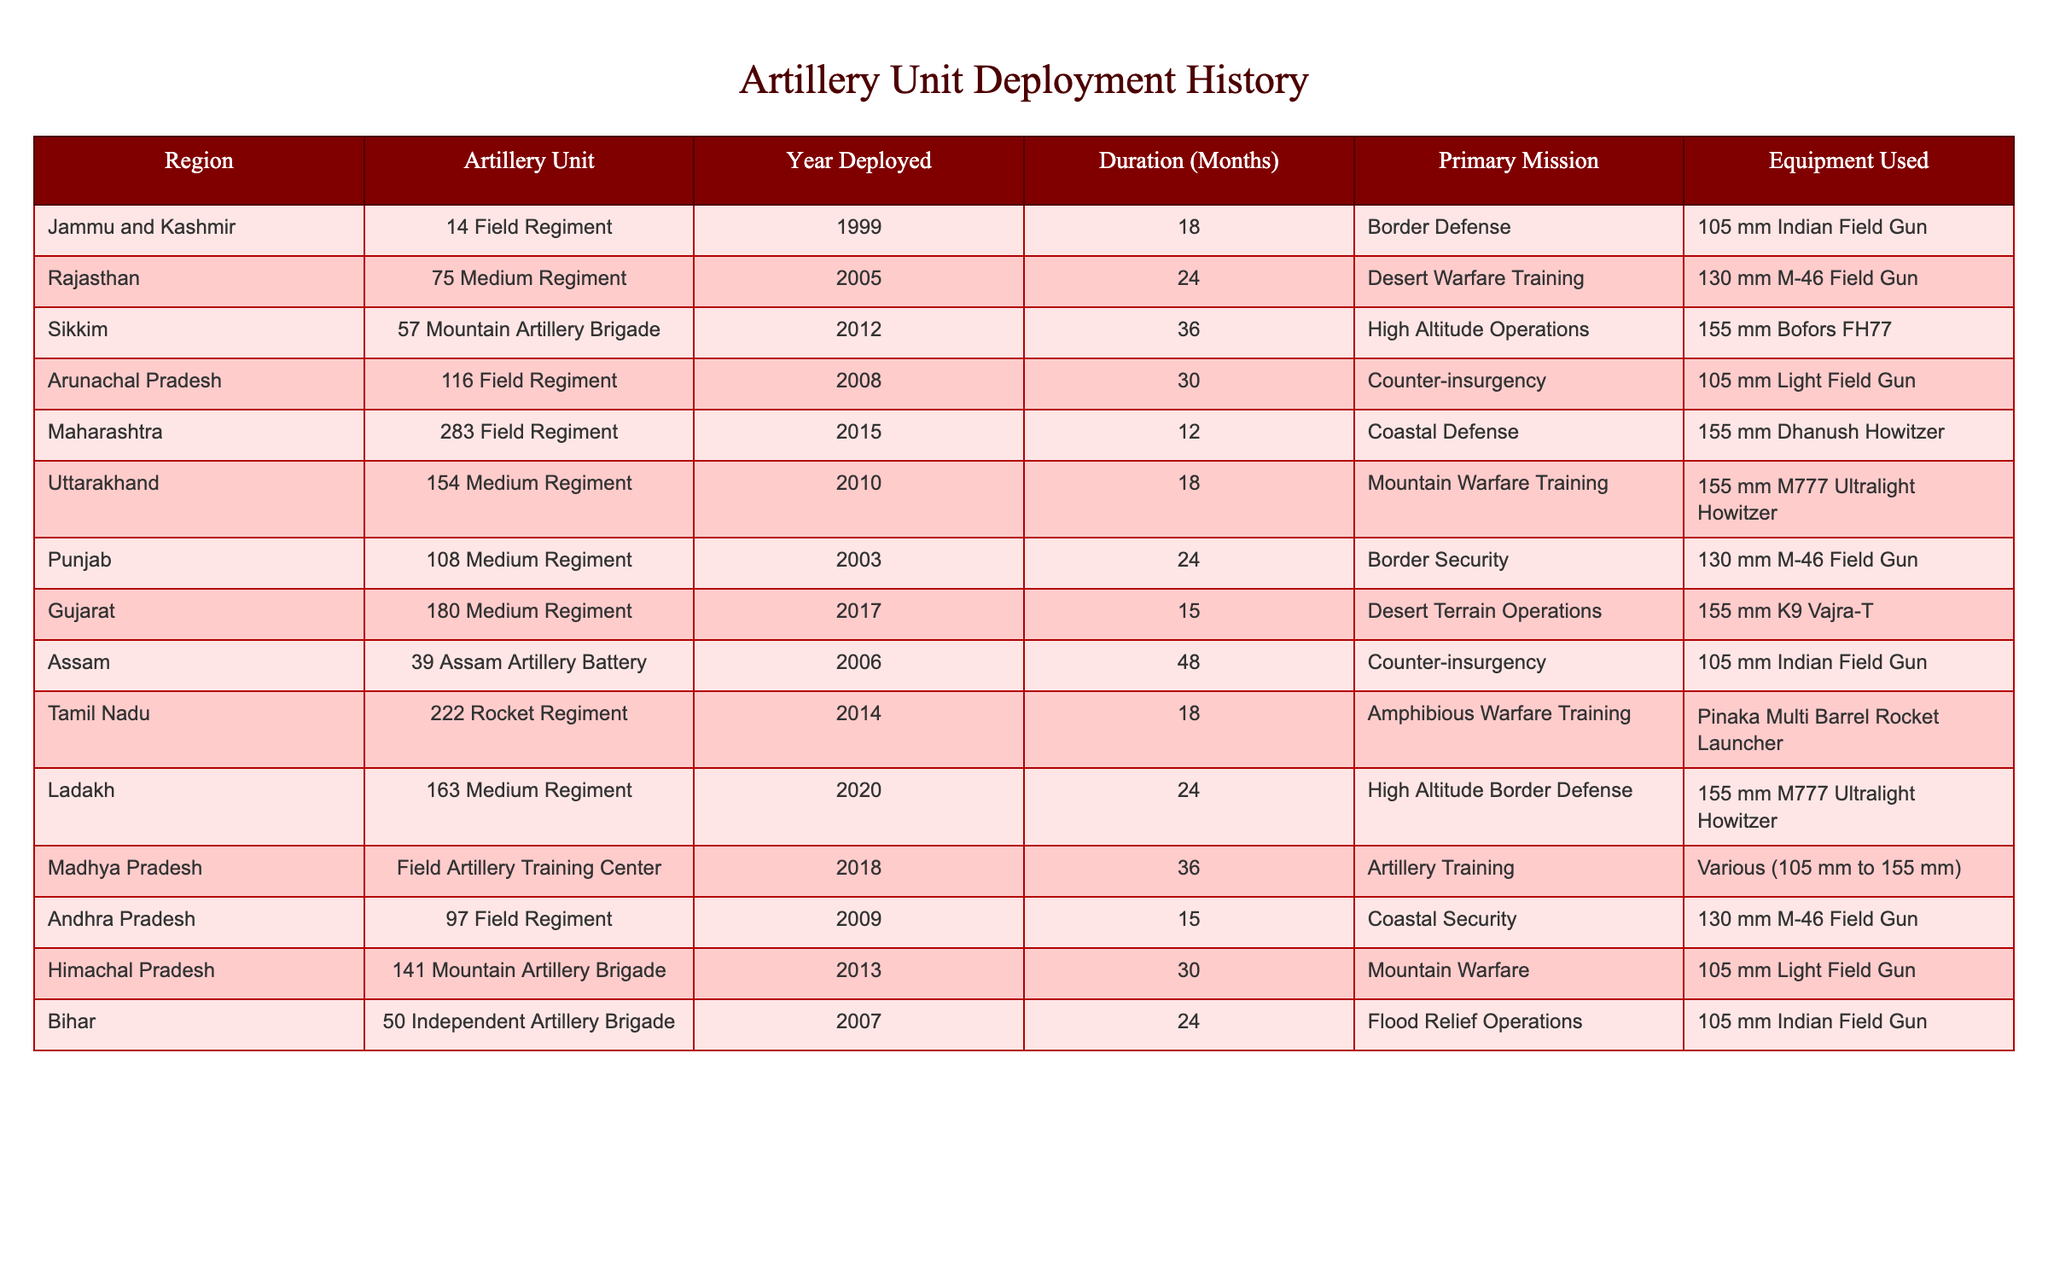What region had the longest deployment duration for artillery units? The longest deployment duration is 48 months, which is for the Assam region. I found this by scanning the "Duration (Months)" column and identifying the maximum value.
Answer: Assam Which artillery unit was deployed in Jammu and Kashmir? The artillery unit deployed in Jammu and Kashmir is the 14 Field Regiment. This is directly stated in the "Artillery Unit" column corresponding to the Jammu and Kashmir row.
Answer: 14 Field Regiment How many months was the 75 Medium Regiment deployed? The 75 Medium Regiment was deployed for 24 months, as noted in the "Duration (Months)" column for that unit.
Answer: 24 months Did any artillery units get deployed for more than 30 months? Yes, the Assam Artillery Battery had a deployment duration of 48 months, which is more than 30 months. To confirm, I checked the "Duration (Months)" column for values greater than 30 and found the relevant entries.
Answer: Yes What is the primary mission of the 222 Rocket Regiment? The primary mission of the 222 Rocket Regiment is Amphibious Warfare Training, as indicated in the "Primary Mission" column for that unit.
Answer: Amphibious Warfare Training How many different types of equipment were used across all the artillery deployments? There are 6 different types of equipment listed in the "Equipment Used" column. I tallied the unique entries from that column: 105 mm Indian Field Gun, 130 mm M-46 Field Gun, 155 mm Bofors FH77, 105 mm Light Field Gun, 155 mm Dhanush Howitzer, 155 mm M777 Ultralight Howitzer, 155 mm K9 Vajra-T, and Pinaka Multi Barrel Rocket Launcher.
Answer: 8 Which region had the second-longest deployment duration? The region with the second-longest deployment duration is Jammu and Kashmir, with 18 months. I sorted the durations in descending order to find the second-highest value after Assam’s 48 months.
Answer: Jammu and Kashmir How many artillery units were deployed for coastal defense missions? There were 2 artillery units deployed for coastal defense missions: the 283 Field Regiment in Maharashtra and the 97 Field Regiment in Andhra Pradesh. I reviewed the "Primary Mission" column and counted the relevant entries.
Answer: 2 What is the average duration of deployment for all the artillery units? The average duration can be calculated by adding all the durations (18 + 24 + 36 + 30 + 12 + 18 + 24 + 15 + 48 + 18 + 24 + 36 + 15 + 30 + 24 =  486) and dividing by the number of units, which is 15, giving an average duration of 486/15 = 32.4 months.
Answer: 32.4 months Which artillery unit used the Pinaka Multi Barrel Rocket Launcher? The artillery unit that used the Pinaka Multi Barrel Rocket Launcher is the 222 Rocket Regiment, as shown in the "Equipment Used" column for that specific unit.
Answer: 222 Rocket Regiment What percentage of the total deployments were in high altitude regions? There were 3 high altitude deployments (Sikkim, Ladakh, and Jammu & Kashmir) out of a total of 15 deployments, giving a percentage of (3/15)*100 = 20%. I calculated this by dividing the number of high altitude deployments by the total and then multiplying by 100.
Answer: 20% 